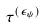Convert formula to latex. <formula><loc_0><loc_0><loc_500><loc_500>\tau ^ { ( \epsilon _ { \psi } ) }</formula> 